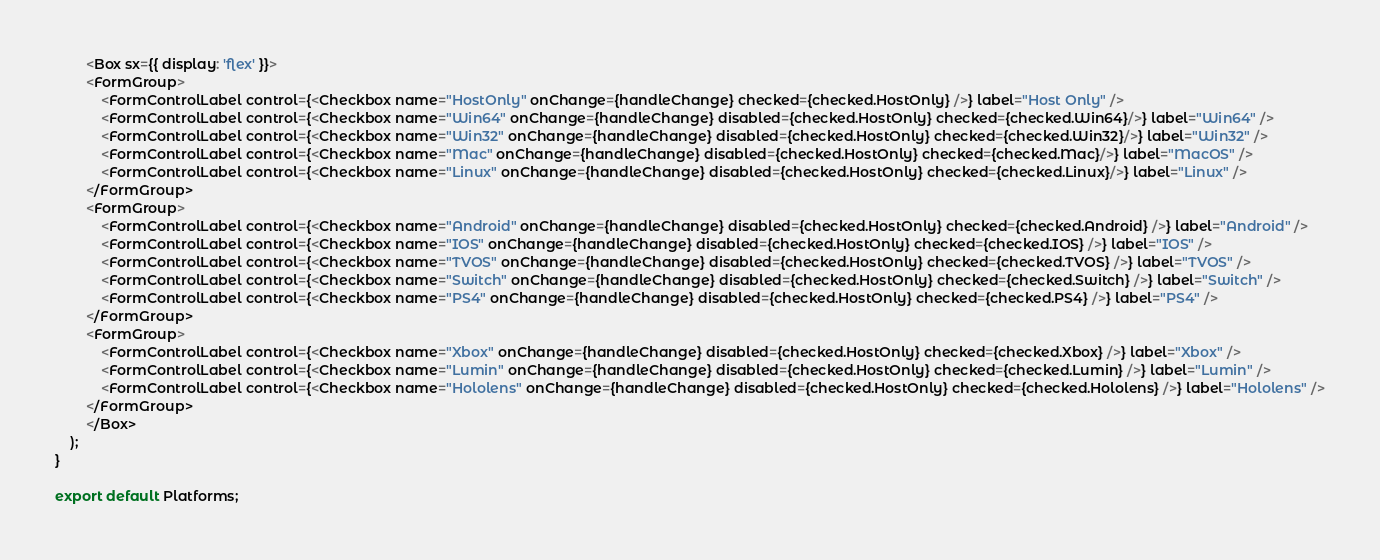<code> <loc_0><loc_0><loc_500><loc_500><_TypeScript_>        <Box sx={{ display: 'flex' }}>
        <FormGroup>
            <FormControlLabel control={<Checkbox name="HostOnly" onChange={handleChange} checked={checked.HostOnly} />} label="Host Only" />
            <FormControlLabel control={<Checkbox name="Win64" onChange={handleChange} disabled={checked.HostOnly} checked={checked.Win64}/>} label="Win64" />
            <FormControlLabel control={<Checkbox name="Win32" onChange={handleChange} disabled={checked.HostOnly} checked={checked.Win32}/>} label="Win32" />
            <FormControlLabel control={<Checkbox name="Mac" onChange={handleChange} disabled={checked.HostOnly} checked={checked.Mac}/>} label="MacOS" />
            <FormControlLabel control={<Checkbox name="Linux" onChange={handleChange} disabled={checked.HostOnly} checked={checked.Linux}/>} label="Linux" />
        </FormGroup>
        <FormGroup>
            <FormControlLabel control={<Checkbox name="Android" onChange={handleChange} disabled={checked.HostOnly} checked={checked.Android} />} label="Android" />
            <FormControlLabel control={<Checkbox name="IOS" onChange={handleChange} disabled={checked.HostOnly} checked={checked.IOS} />} label="IOS" />
            <FormControlLabel control={<Checkbox name="TVOS" onChange={handleChange} disabled={checked.HostOnly} checked={checked.TVOS} />} label="TVOS" />
            <FormControlLabel control={<Checkbox name="Switch" onChange={handleChange} disabled={checked.HostOnly} checked={checked.Switch} />} label="Switch" />
            <FormControlLabel control={<Checkbox name="PS4" onChange={handleChange} disabled={checked.HostOnly} checked={checked.PS4} />} label="PS4" />
        </FormGroup>
        <FormGroup>
            <FormControlLabel control={<Checkbox name="Xbox" onChange={handleChange} disabled={checked.HostOnly} checked={checked.Xbox} />} label="Xbox" />
            <FormControlLabel control={<Checkbox name="Lumin" onChange={handleChange} disabled={checked.HostOnly} checked={checked.Lumin} />} label="Lumin" />
            <FormControlLabel control={<Checkbox name="Hololens" onChange={handleChange} disabled={checked.HostOnly} checked={checked.Hololens} />} label="Hololens" />
        </FormGroup>
        </Box>
    );
}

export default Platforms;
</code> 